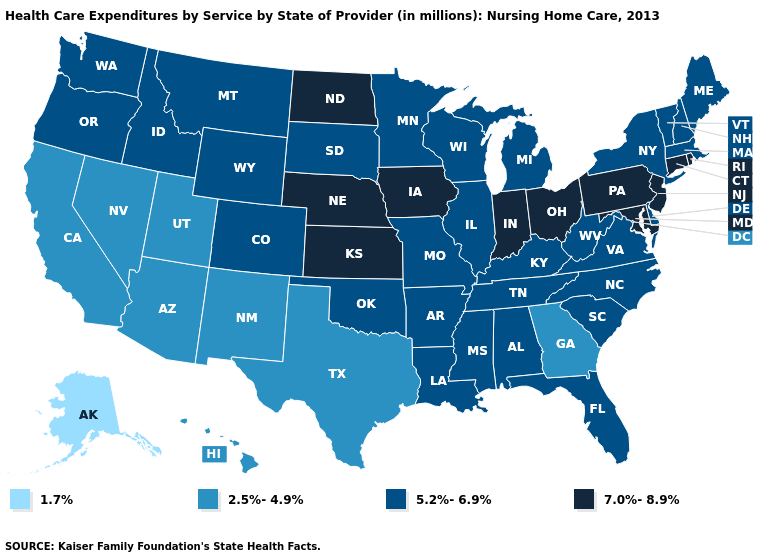Name the states that have a value in the range 5.2%-6.9%?
Keep it brief. Alabama, Arkansas, Colorado, Delaware, Florida, Idaho, Illinois, Kentucky, Louisiana, Maine, Massachusetts, Michigan, Minnesota, Mississippi, Missouri, Montana, New Hampshire, New York, North Carolina, Oklahoma, Oregon, South Carolina, South Dakota, Tennessee, Vermont, Virginia, Washington, West Virginia, Wisconsin, Wyoming. What is the highest value in states that border Nebraska?
Keep it brief. 7.0%-8.9%. Which states have the highest value in the USA?
Concise answer only. Connecticut, Indiana, Iowa, Kansas, Maryland, Nebraska, New Jersey, North Dakota, Ohio, Pennsylvania, Rhode Island. What is the value of Virginia?
Quick response, please. 5.2%-6.9%. Does Oregon have the same value as Iowa?
Keep it brief. No. What is the highest value in states that border Massachusetts?
Short answer required. 7.0%-8.9%. How many symbols are there in the legend?
Write a very short answer. 4. What is the highest value in states that border Washington?
Concise answer only. 5.2%-6.9%. Does the first symbol in the legend represent the smallest category?
Answer briefly. Yes. Does Iowa have the lowest value in the MidWest?
Be succinct. No. Does Alaska have the lowest value in the USA?
Give a very brief answer. Yes. Name the states that have a value in the range 2.5%-4.9%?
Answer briefly. Arizona, California, Georgia, Hawaii, Nevada, New Mexico, Texas, Utah. What is the value of Missouri?
Concise answer only. 5.2%-6.9%. What is the highest value in the USA?
Give a very brief answer. 7.0%-8.9%. Does New York have the lowest value in the Northeast?
Quick response, please. Yes. 